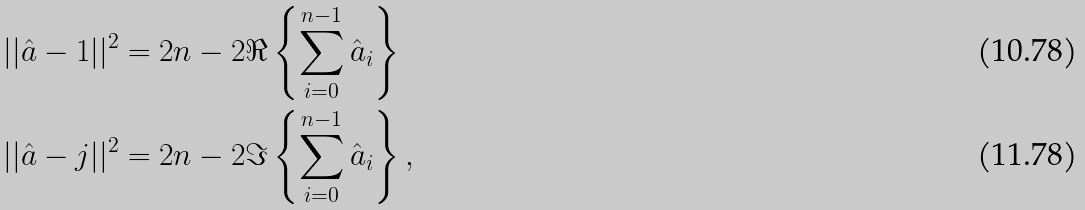Convert formula to latex. <formula><loc_0><loc_0><loc_500><loc_500>| | \hat { a } - 1 | | ^ { 2 } & = 2 n - 2 \Re \left \{ \sum _ { i = 0 } ^ { n - 1 } \hat { a } _ { i } \right \} \\ | | \hat { a } - j | | ^ { 2 } & = 2 n - 2 \Im \left \{ \sum _ { i = 0 } ^ { n - 1 } \hat { a } _ { i } \right \} ,</formula> 